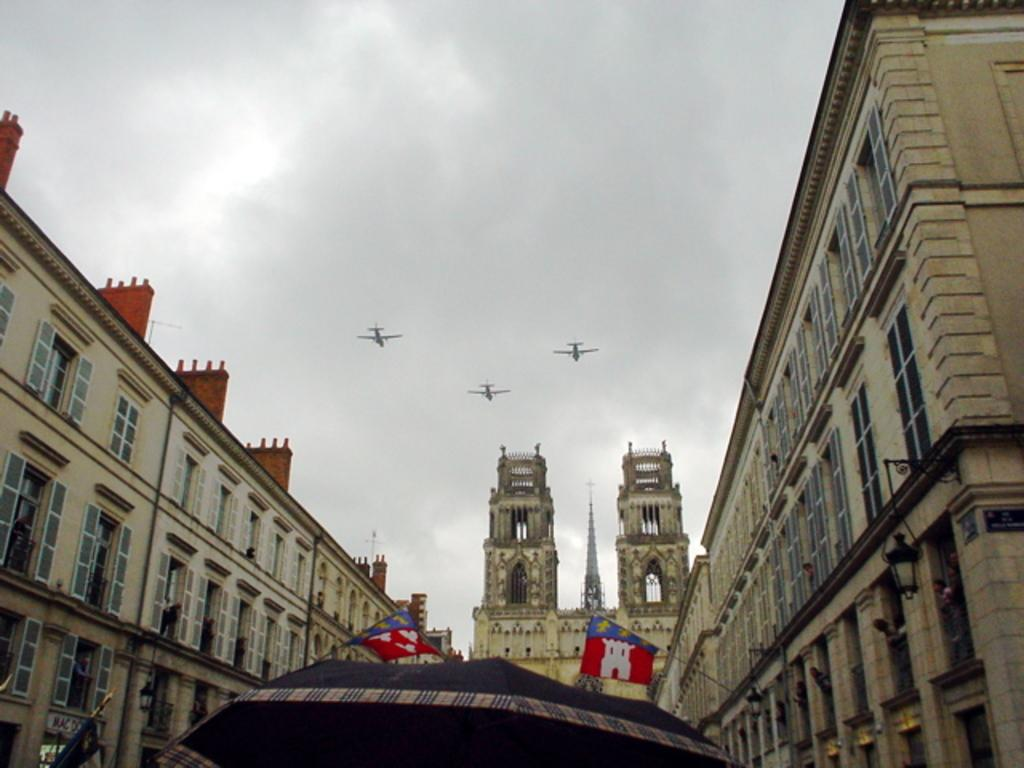What can be seen in the sky in the image? Clouds are visible in the image. What type of structures are present in the image? There are buildings and towers in the image. What architectural features can be seen on the buildings? Windows are visible in the image. Are there any symbols or emblems in the image? Flags are present in the image. What type of temporary shelter is visible in the image? There is a tent in the image. Can you see a boy holding a wire and a whip in the image? There is no boy holding a wire and a whip in the image. 